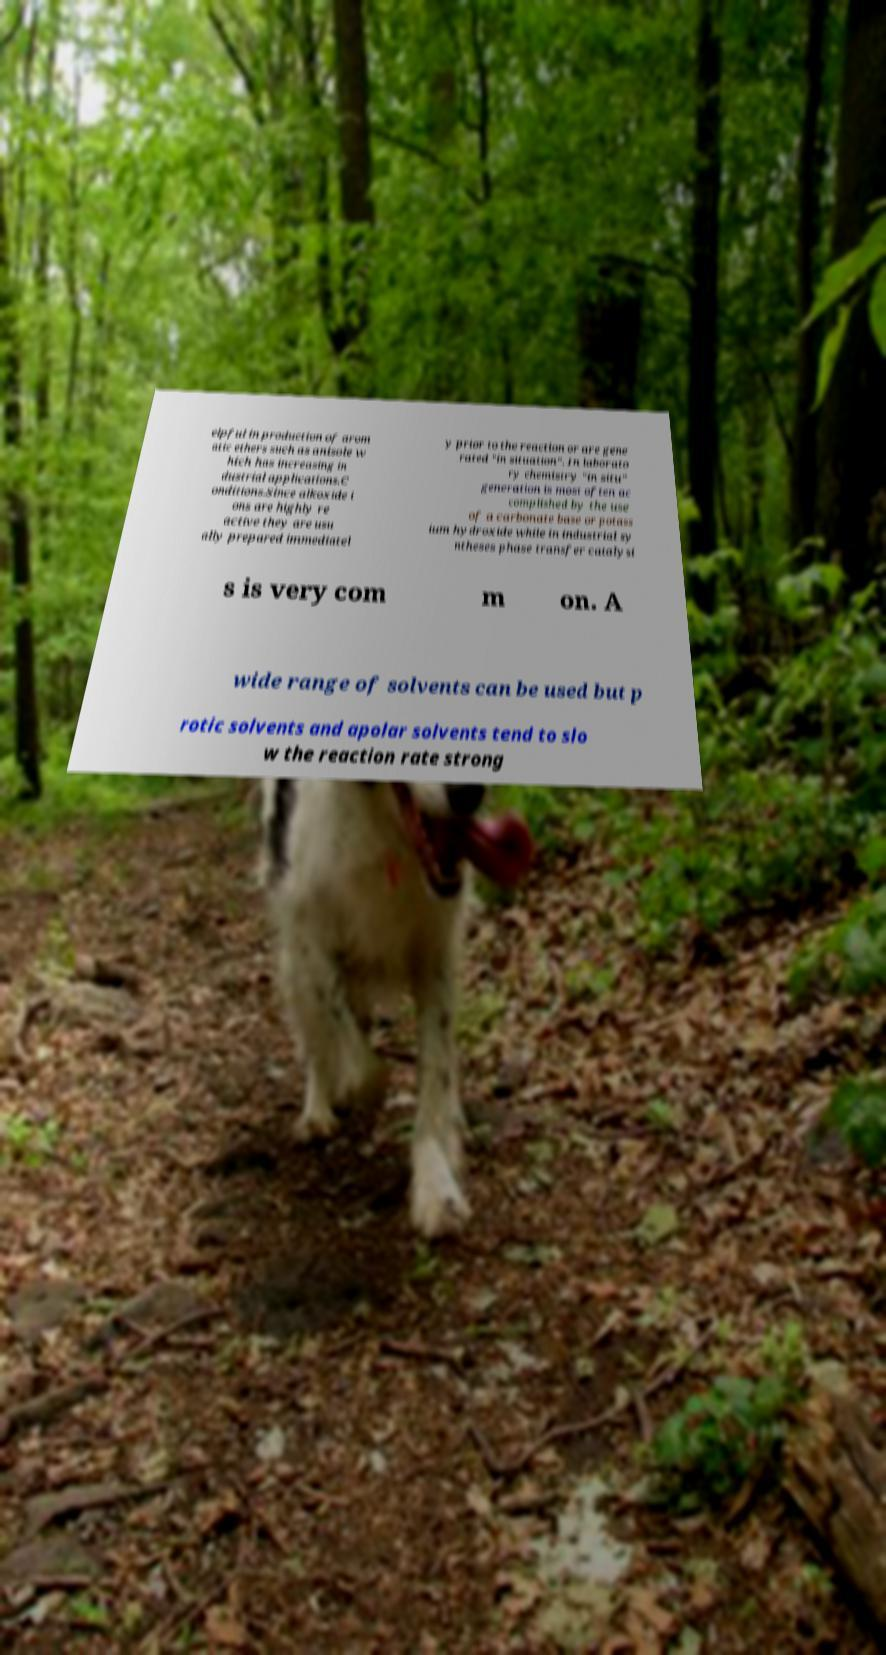I need the written content from this picture converted into text. Can you do that? elpful in production of arom atic ethers such as anisole w hich has increasing in dustrial applications.C onditions.Since alkoxide i ons are highly re active they are usu ally prepared immediatel y prior to the reaction or are gene rated "in situation". In laborato ry chemistry "in situ" generation is most often ac complished by the use of a carbonate base or potass ium hydroxide while in industrial sy ntheses phase transfer catalysi s is very com m on. A wide range of solvents can be used but p rotic solvents and apolar solvents tend to slo w the reaction rate strong 